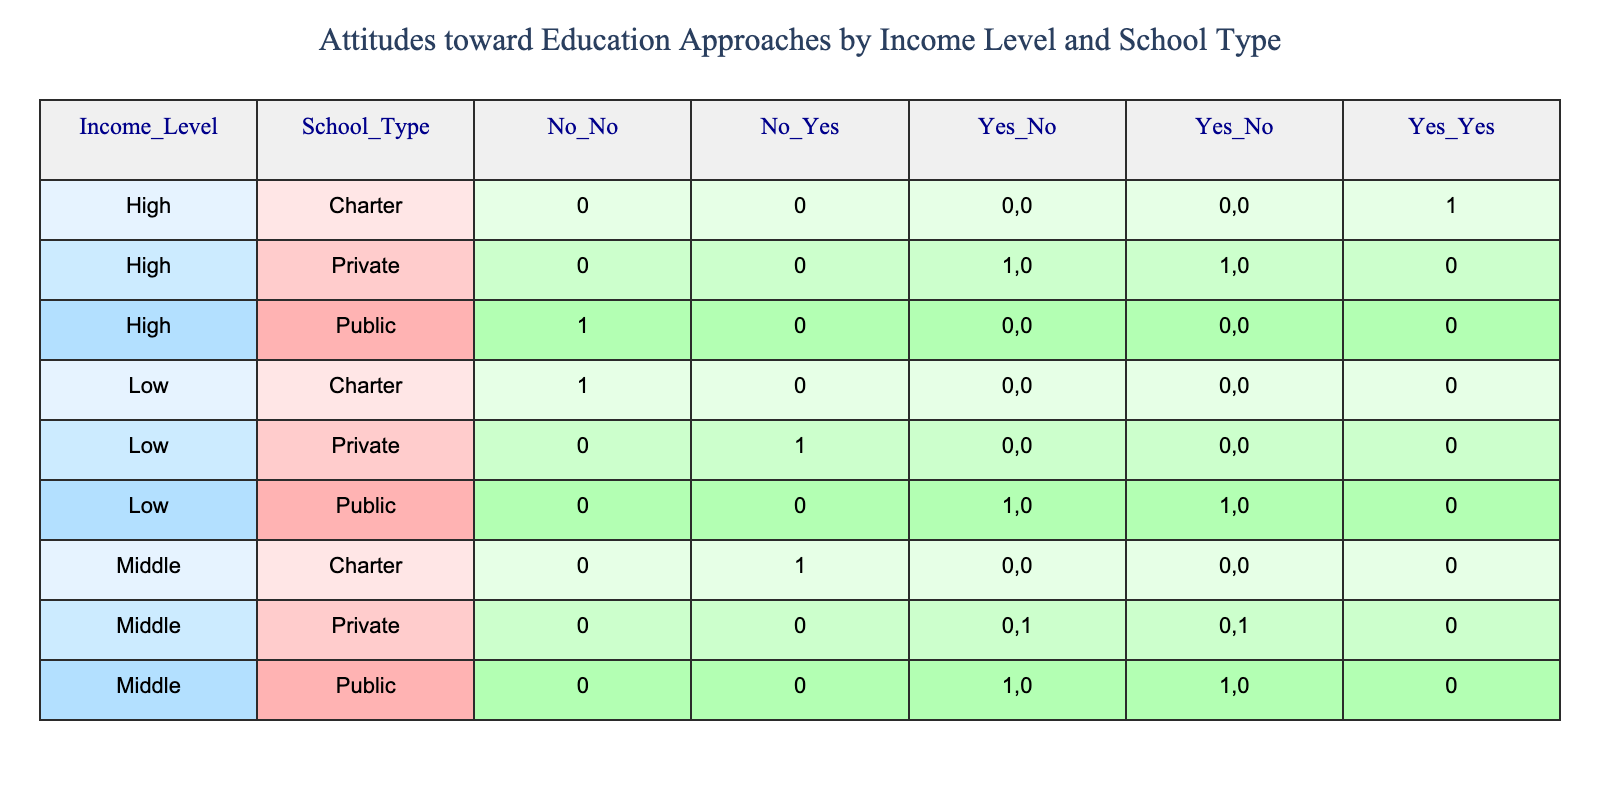What is the income level for families preferring traditional education in public schools? From the table, the only entry for families preferring traditional education in public schools is under the 'Low' income level. Therefore, the income level for these families is low.
Answer: Low How many families prefer homeschooling in middle-income private schools? Checking the table, we see that there is one entry for middle-income private schools, and the preference for homeschooling is indicated as "No." Thus, no families prefer homeschooling in this category.
Answer: 0 What is the preferred school type for families with a high income that do not prefer traditional education? The table shows that high-income families that do not prefer traditional education chose charter schools. Therefore, the preferred school type for this group is charter schools.
Answer: Charter School Do any low-income families prefer charter schools? Reviewing the table shows that there is one entry for low-income families, where the school type is charter, and the preference is for charter schools. Thus, yes, there are low-income families who prefer charter schools.
Answer: Yes What is the total number of families that prefer private education across all income levels? To find this answer, we must look for all entries where school type is private. The table shows one private school entry each in the low, middle, and high-income levels. Summing these gives us 3 families preferring private education.
Answer: 3 How many middle-income families prefer homeschooling compared to low-income families? From the table, middle-income families prefer homeschooling (1 family), while low-income families do not prefer homeschooling (0 families). Therefore, middle-income families have a preference while low-income families do not. Thus, the difference is 1 family in favor of middle-income families.
Answer: 1 What percentage of high-income families prefer charter schools? The table presents two entries for high-income families, and out of those, one prefers charter schools. Therefore, calculating the percentage gives us (1/2) * 100% = 50%.
Answer: 50% Do middle-income families exclusively prefer either public or private schools? Inspecting the middle-income entries reveals that families prefer both public and private schools. Therefore, they do not exclusively prefer one type; they prefer both types of schools.
Answer: No How many families prefer public schools in total, across all income levels? The table shows that there is one entry for low-income, one for middle-income, and one for high-income, resulting in a total of 3 families preferring public schools.
Answer: 3 